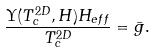<formula> <loc_0><loc_0><loc_500><loc_500>\frac { \Upsilon ( T _ { c } ^ { 2 D } , H ) H _ { e f f } } { T _ { c } ^ { 2 D } } = \bar { g } .</formula> 